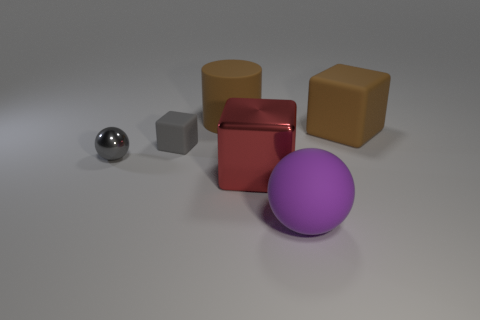How many metallic objects are either large blocks or red cylinders?
Offer a terse response. 1. What number of small rubber cubes are in front of the big block left of the big brown cube?
Offer a terse response. 0. The rubber object that is both to the left of the purple matte thing and to the right of the small gray matte object has what shape?
Your answer should be compact. Cylinder. The large brown object that is in front of the large brown thing behind the block that is right of the big purple ball is made of what material?
Your answer should be very brief. Rubber. What size is the sphere that is the same color as the tiny matte block?
Provide a short and direct response. Small. What is the material of the small ball?
Your answer should be compact. Metal. Does the brown block have the same material as the sphere that is right of the cylinder?
Your answer should be very brief. Yes. The metal object behind the large cube that is to the left of the large matte sphere is what color?
Offer a very short reply. Gray. There is a object that is in front of the gray block and on the left side of the big red metal cube; what size is it?
Provide a succinct answer. Small. What number of other things are the same shape as the small gray metallic object?
Provide a short and direct response. 1. 